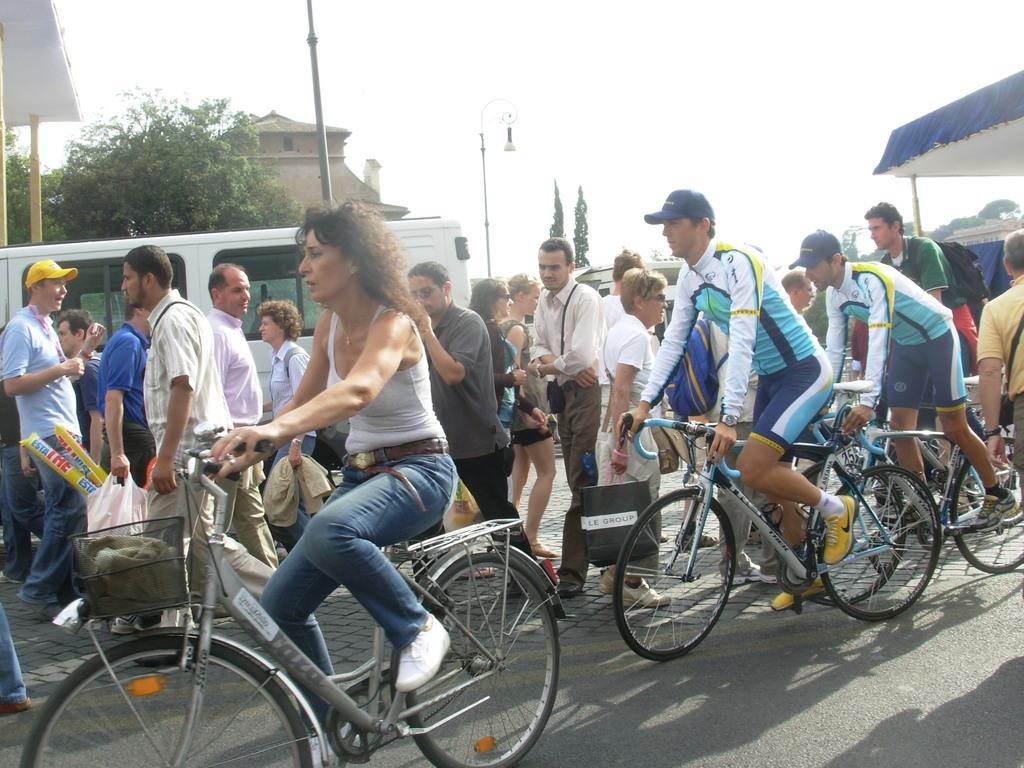Could you give a brief overview of what you see in this image? There are three persons riding on cycles. Beside them many persons walking. In the background there is a vehicle, tree and a building. A person wearing a white and blue dress is wearing a cap. 